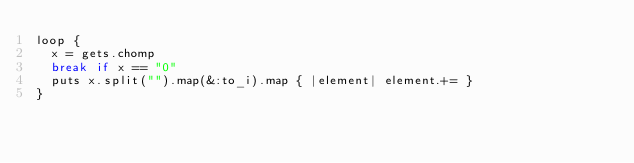<code> <loc_0><loc_0><loc_500><loc_500><_Ruby_>loop {
  x = gets.chomp
  break if x == "0"
  puts x.split("").map(&:to_i).map { |element| element.+= }
}
</code> 